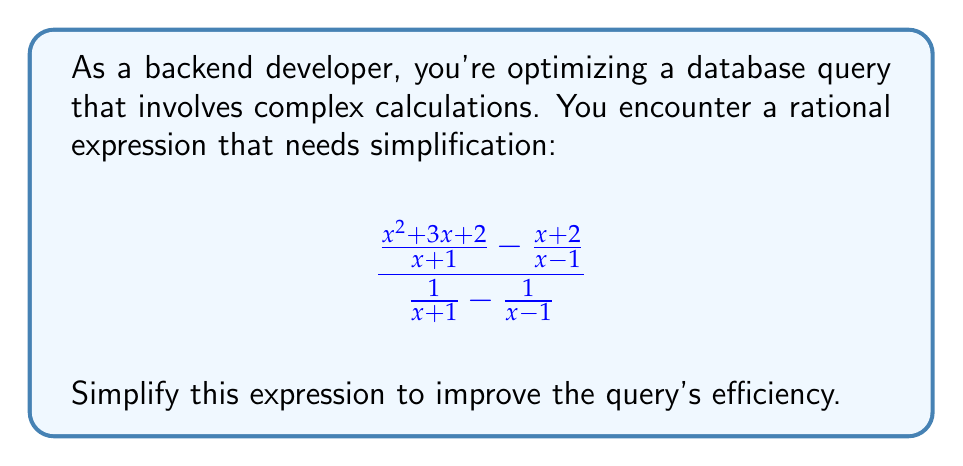Give your solution to this math problem. Let's simplify this complex rational expression step by step:

1) First, let's find a common denominator for the numerator and simplify:
   $$\frac{(x^2 + 3x + 2)(x - 1) - (x + 2)(x + 1)}{(x + 1)(x - 1)}$$

2) Expand the numerator:
   $$\frac{(x^3 + 2x^2 - x^2 - 3x - 2x + 2) - (x^2 + x + 2x + 2)}{(x + 1)(x - 1)}$$

3) Simplify the numerator:
   $$\frac{x^3 + x^2 - 5x - x^2 - 3x - 2}{(x + 1)(x - 1)} = \frac{x^3 - 8x - 2}{(x + 1)(x - 1)}$$

4) Now, let's simplify the denominator of the original expression:
   $$\frac{1}{x + 1} - \frac{1}{x - 1} = \frac{x - 1 - (x + 1)}{(x + 1)(x - 1)} = \frac{-2}{(x + 1)(x - 1)}$$

5) Now our expression looks like:
   $$\frac{x^3 - 8x - 2}{(x + 1)(x - 1)} \div \frac{-2}{(x + 1)(x - 1)}$$

6) Dividing by a fraction is the same as multiplying by its reciprocal:
   $$\frac{x^3 - 8x - 2}{(x + 1)(x - 1)} \cdot \frac{(x + 1)(x - 1)}{-2}$$

7) The $(x + 1)(x - 1)$ terms cancel out:
   $$\frac{x^3 - 8x - 2}{-2}$$

8) Simplify by dividing both terms by -2:
   $$-\frac{1}{2}x^3 + 4x + 1$$
Answer: $-\frac{1}{2}x^3 + 4x + 1$ 